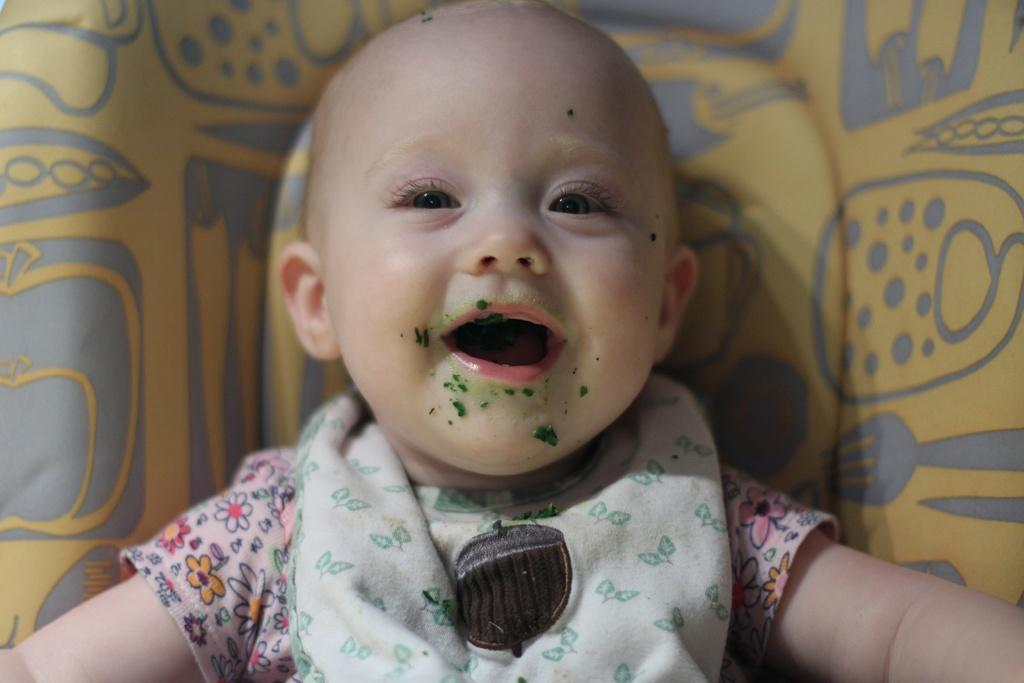What is the main subject of the image? There is a baby in the image. What is the baby doing in the image? The baby is smiling. What can be seen in the background of the image? There is a yellow object in the background that resembles a bed. What type of behavior does the queen exhibit in the image? There is no queen present in the image; it features a baby who is smiling. Does the existence of the baby in the image prove the existence of a parallel universe? The presence of the baby in the image does not prove the existence of a parallel universe, as the image is a representation of a single reality. 